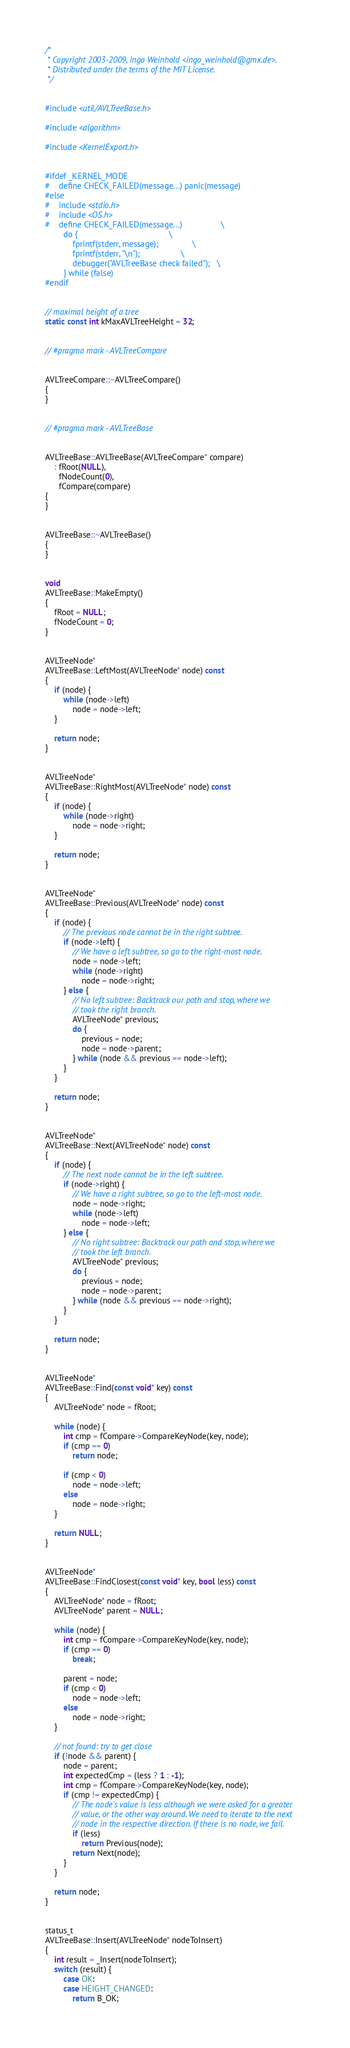Convert code to text. <code><loc_0><loc_0><loc_500><loc_500><_C++_>/*
 * Copyright 2003-2009, Ingo Weinhold <ingo_weinhold@gmx.de>.
 * Distributed under the terms of the MIT License.
 */


#include <util/AVLTreeBase.h>

#include <algorithm>

#include <KernelExport.h>


#ifdef _KERNEL_MODE
#	define CHECK_FAILED(message...)	panic(message)
#else
#	include <stdio.h>
#	include <OS.h>
#	define CHECK_FAILED(message...)					\
		do {										\
			fprintf(stderr, message);				\
			fprintf(stderr, "\n");					\
			debugger("AVLTreeBase check failed");	\
		} while (false)
#endif


// maximal height of a tree
static const int kMaxAVLTreeHeight = 32;


// #pragma mark - AVLTreeCompare


AVLTreeCompare::~AVLTreeCompare()
{
}


// #pragma mark - AVLTreeBase


AVLTreeBase::AVLTreeBase(AVLTreeCompare* compare)
	: fRoot(NULL),
	  fNodeCount(0),
	  fCompare(compare)
{
}


AVLTreeBase::~AVLTreeBase()
{
}


void
AVLTreeBase::MakeEmpty()
{
	fRoot = NULL;
	fNodeCount = 0;
}


AVLTreeNode*
AVLTreeBase::LeftMost(AVLTreeNode* node) const
{
	if (node) {
		while (node->left)
			node = node->left;
	}

	return node;
}


AVLTreeNode*
AVLTreeBase::RightMost(AVLTreeNode* node) const
{
	if (node) {
		while (node->right)
			node = node->right;
	}

	return node;
}


AVLTreeNode*
AVLTreeBase::Previous(AVLTreeNode* node) const
{
	if (node) {
		// The previous node cannot be in the right subtree.
		if (node->left) {
			// We have a left subtree, so go to the right-most node.
			node = node->left;
			while (node->right)
				node = node->right;
		} else {
			// No left subtree: Backtrack our path and stop, where we
			// took the right branch.
			AVLTreeNode* previous;
			do {
				previous = node;
				node = node->parent;
			} while (node && previous == node->left);
		}
	}

	return node;
}


AVLTreeNode*
AVLTreeBase::Next(AVLTreeNode* node) const
{
	if (node) {
		// The next node cannot be in the left subtree.
		if (node->right) {
			// We have a right subtree, so go to the left-most node.
			node = node->right;
			while (node->left)
				node = node->left;
		} else {
			// No right subtree: Backtrack our path and stop, where we
			// took the left branch.
			AVLTreeNode* previous;
			do {
				previous = node;
				node = node->parent;
			} while (node && previous == node->right);
		}
	}

	return node;
}


AVLTreeNode*
AVLTreeBase::Find(const void* key) const
{
	AVLTreeNode* node = fRoot;

	while (node) {
		int cmp = fCompare->CompareKeyNode(key, node);
		if (cmp == 0)
			return node;

		if (cmp < 0)
			node = node->left;
		else
			node = node->right;
	}

	return NULL;
}


AVLTreeNode*
AVLTreeBase::FindClosest(const void* key, bool less) const
{
	AVLTreeNode* node = fRoot;
	AVLTreeNode* parent = NULL;

	while (node) {
		int cmp = fCompare->CompareKeyNode(key, node);
		if (cmp == 0)
			break;

		parent = node;
		if (cmp < 0)
			node = node->left;
		else
			node = node->right;
	}

	// not found: try to get close
	if (!node && parent) {
		node = parent;
		int expectedCmp = (less ? 1 : -1);
		int cmp = fCompare->CompareKeyNode(key, node);
		if (cmp != expectedCmp) {
			// The node's value is less although we were asked for a greater
			// value, or the other way around. We need to iterate to the next
			// node in the respective direction. If there is no node, we fail.
			if (less)
				return Previous(node);
			return Next(node);
		}
	}

	return node;
}


status_t
AVLTreeBase::Insert(AVLTreeNode* nodeToInsert)
{
	int result = _Insert(nodeToInsert);
	switch (result) {
		case OK:
		case HEIGHT_CHANGED:
			return B_OK;</code> 